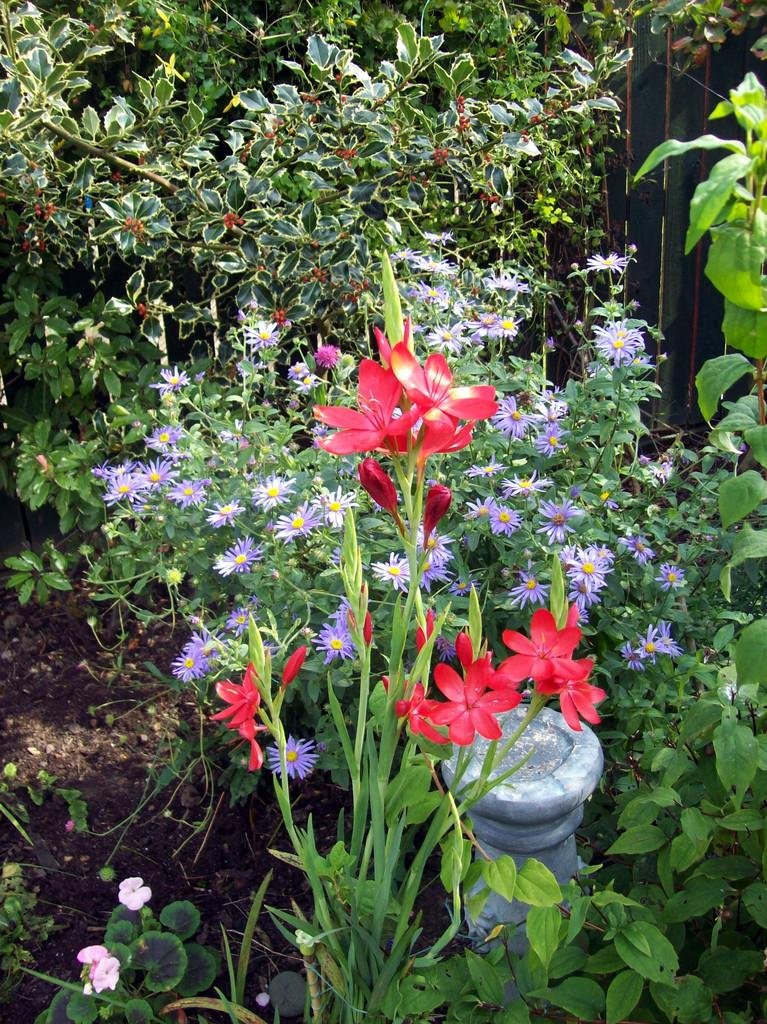What type of living organisms can be seen in the image? Plants can be seen in the image. Are there any specific features of the plants? Some of the plants have flowers. What else is present among the plants? There is an object present among the plants. What type of pencil can be seen among the plants in the image? There is no pencil present among the plants in the image. Can you tell me how many sticks are visible among the plants? There is no mention of sticks in the image, only plants and an unidentified object. 